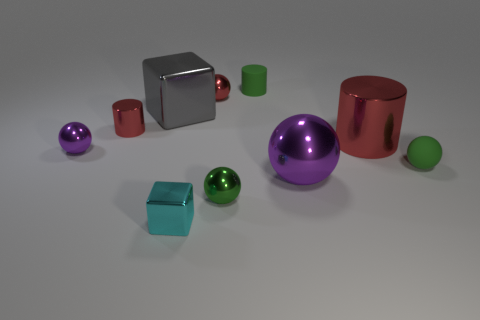Can you describe the colors of the objects in the image? Certainly! In the image, you can observe objects with various colors: there is a large purple sphere, a red cylinder, a green small sphere, and two cubes—one appearing silver and the other turquoise. Additionally, there's a small purple sphere and a green cylinder. 